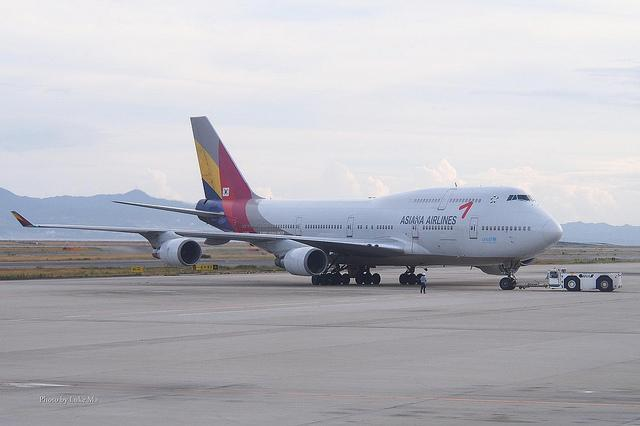This vehicle is most likely from? asia 